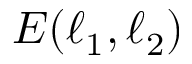Convert formula to latex. <formula><loc_0><loc_0><loc_500><loc_500>E ( \ell _ { 1 } , \ell _ { 2 } )</formula> 